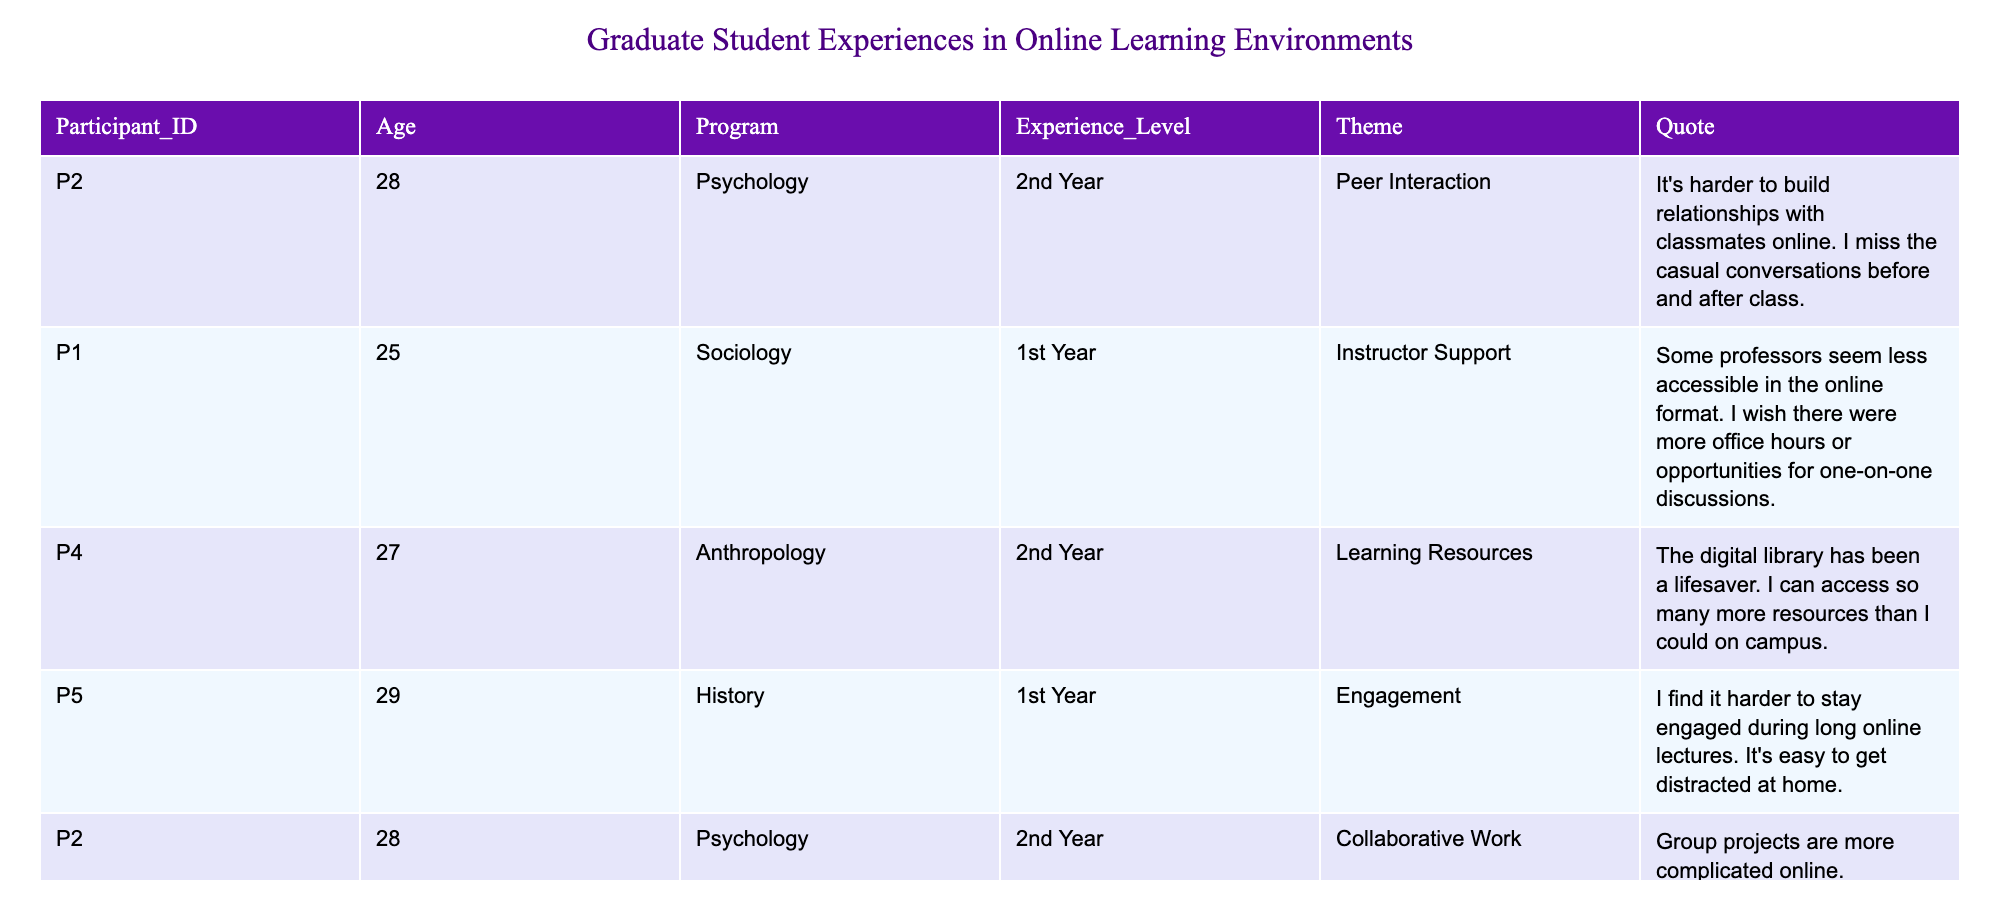What is the age of the participant from the Sociology program? The table indicates that Participant P1 from the Sociology program is 25 years old.
Answer: 25 How many different themes are mentioned in the table? The table lists 6 unique themes: Peer Interaction, Instructor Support, Learning Resources, Engagement, Collaborative Work, Research Challenges, Global Perspective, Mental Health, and Future of Education, totaling to 8 themes.
Answer: 8 Which participant reported experiencing challenges with mental health during online learning? Participant P1 mentioned challenges with mental health, stating the isolation was tough.
Answer: Participant P1 Which program has the oldest participant in the table? The oldest participant is in the Political Science program, with an age of 33 (Participant P6).
Answer: Political Science What is the average age of participants in the table? The ages are 28, 25, 27, 29, 28, 33, 25, and 31, summing to 226. Divided by 8 participants gives an average age of 28.25.
Answer: 28.25 How many participants are in their first year of study? The table shows that there are two first-year participants: P1 and P5.
Answer: 2 Did any participant express a positive view about the online environment? Yes, Participant P6 highlighted the ease of collaboration with international students as a positive aspect of online learning.
Answer: Yes How does the engagement experience during online lectures vary between the first-year and second-year students? P5 (1st Year) struggles with engagement in long lectures, while P2 (2nd Year) finds collaborative work more complicated, indicating both have challenges but in different areas.
Answer: Varies by theme Identify the participant who mentioned the digital library as a resource. Participant P4 noted that the digital library has been a lifesaver for accessing resources.
Answer: Participant P4 Which theme received the most mentions from participants? The theme "Peer Interaction" and "Engagement" were explicitly mentioned by participants P2 and P5 respectively, but others also touch on related issues indicating no single most mentioned theme.
Answer: Equal mentions across several themes 